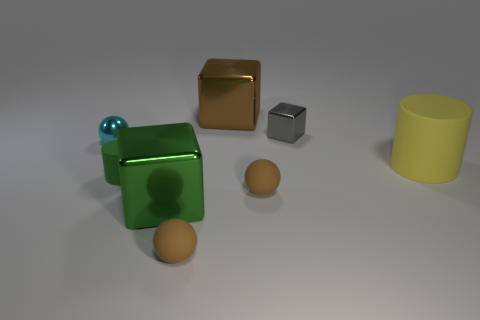What material is the large green object that is the same shape as the gray object?
Offer a very short reply. Metal. Is there any other thing that is the same material as the small cylinder?
Your response must be concise. Yes. Are the tiny sphere that is behind the yellow rubber thing and the cube behind the gray cube made of the same material?
Your answer should be compact. Yes. What color is the rubber cylinder in front of the yellow rubber cylinder on the right side of the large metallic block in front of the cyan ball?
Offer a very short reply. Green. How many other things are the same shape as the large green metal object?
Provide a succinct answer. 2. Is the color of the tiny block the same as the big rubber cylinder?
Make the answer very short. No. How many objects are either balls or tiny rubber things to the right of the big brown metal object?
Give a very brief answer. 3. Is there another green rubber cylinder that has the same size as the green rubber cylinder?
Provide a succinct answer. No. Are the gray block and the small cyan ball made of the same material?
Offer a very short reply. Yes. What number of objects are gray metallic things or tiny red cylinders?
Your answer should be compact. 1. 